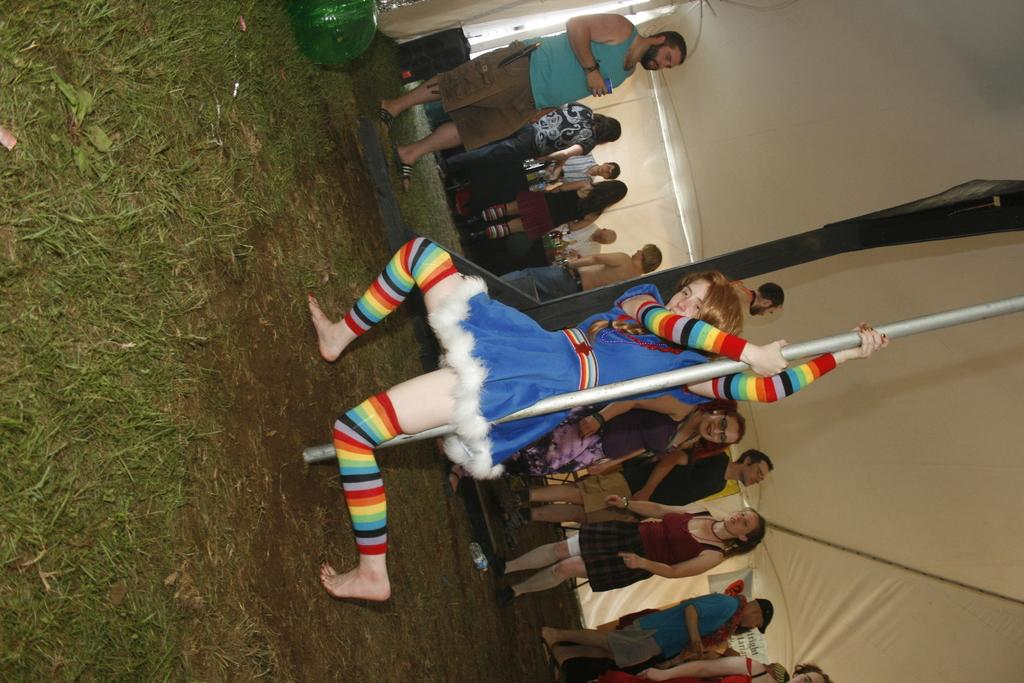What are the people in the image doing? The people in the image are standing on the ground. Can you describe any objects that the people are holding? One of the people is holding a pole. What can be seen in the background of the image? There is a tent visible in the background. What type of hydrant is present in the image? There is no hydrant present in the image. Can you describe the ghost that is standing with the people in the image? There is no ghost present in the image; only people and a pole are visible. 